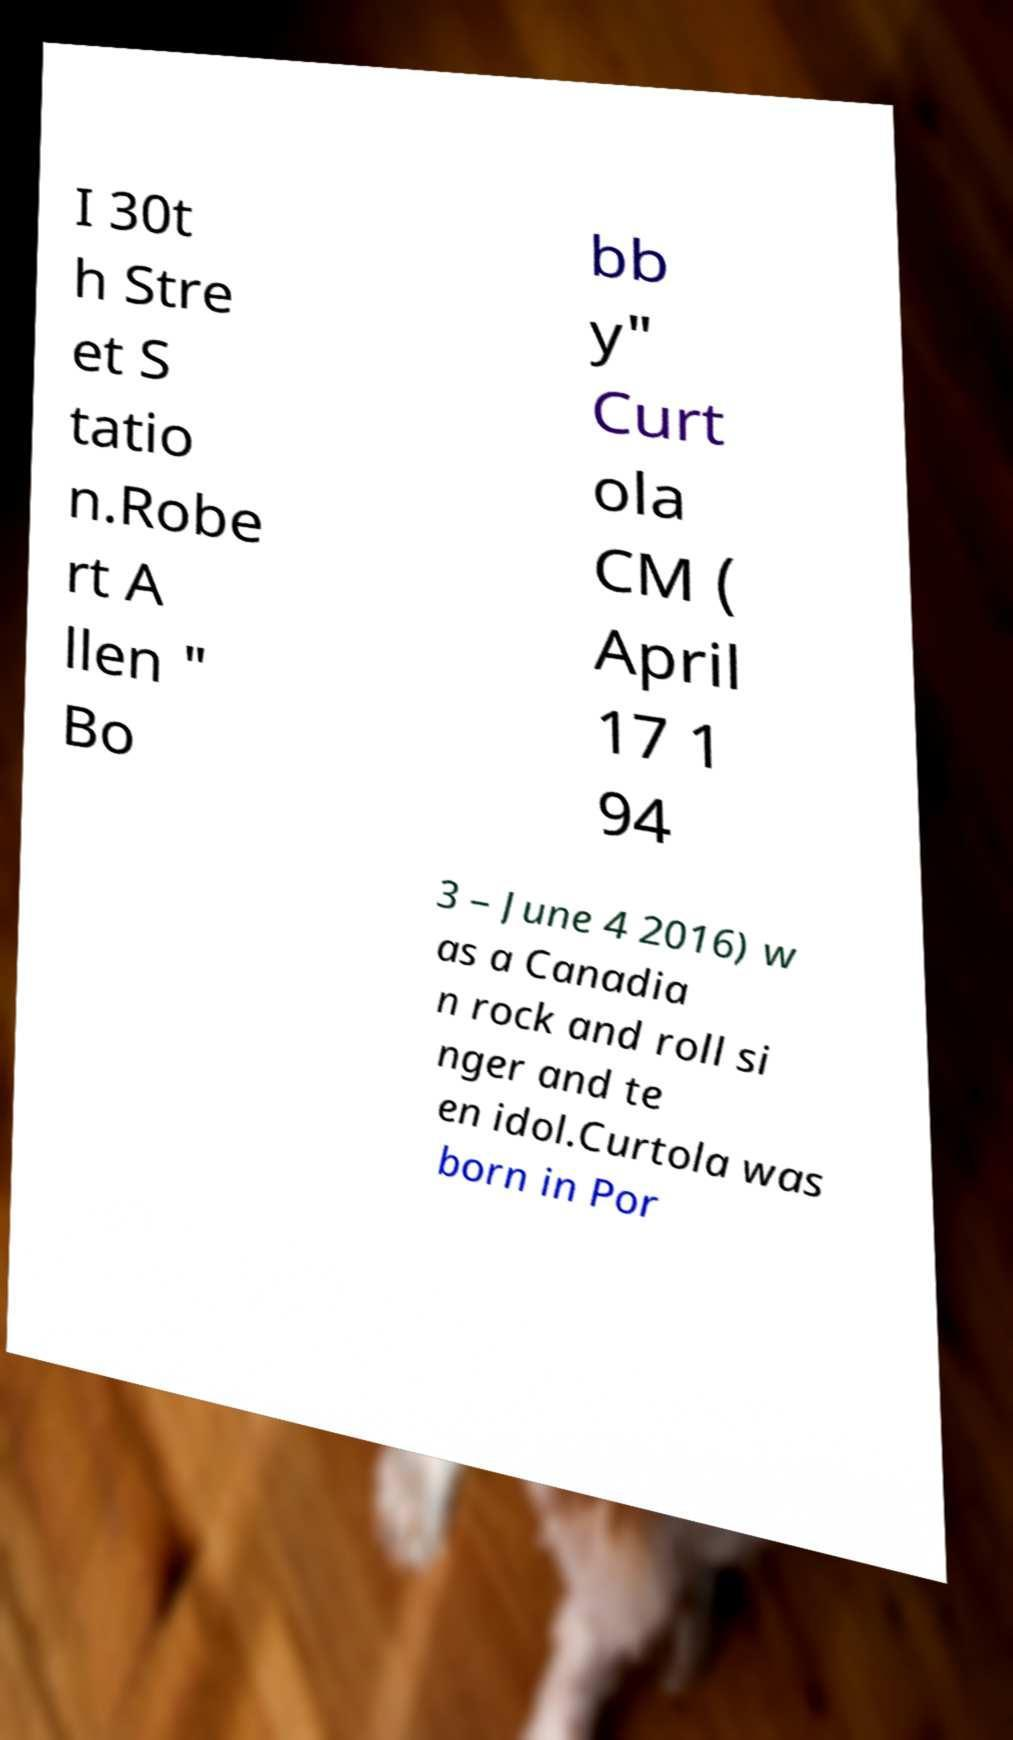There's text embedded in this image that I need extracted. Can you transcribe it verbatim? I 30t h Stre et S tatio n.Robe rt A llen " Bo bb y" Curt ola CM ( April 17 1 94 3 – June 4 2016) w as a Canadia n rock and roll si nger and te en idol.Curtola was born in Por 